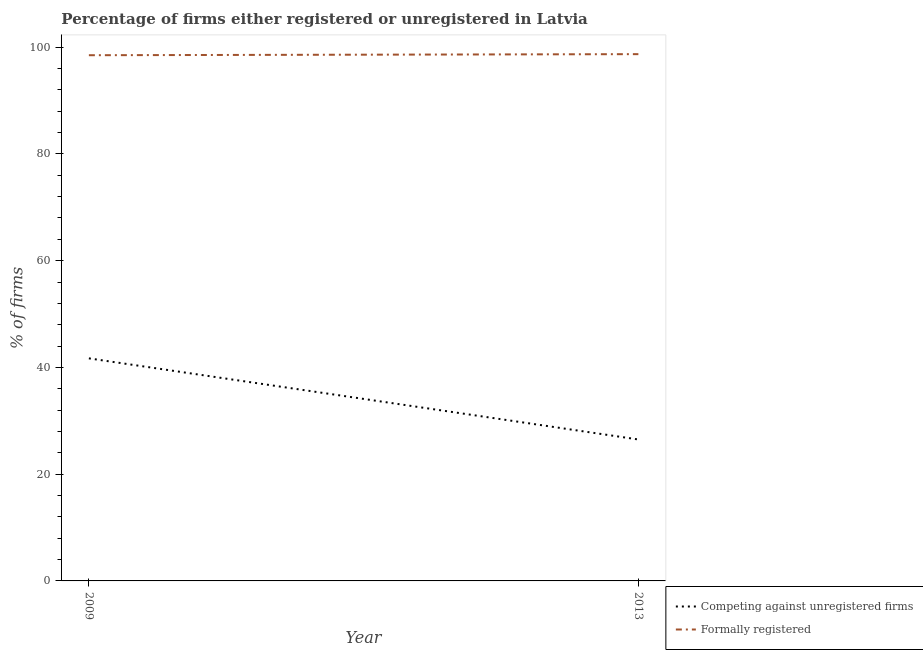Is the number of lines equal to the number of legend labels?
Offer a terse response. Yes. Across all years, what is the maximum percentage of registered firms?
Your response must be concise. 41.7. Across all years, what is the minimum percentage of formally registered firms?
Your answer should be very brief. 98.5. In which year was the percentage of formally registered firms maximum?
Make the answer very short. 2013. In which year was the percentage of registered firms minimum?
Make the answer very short. 2013. What is the total percentage of registered firms in the graph?
Give a very brief answer. 68.2. What is the difference between the percentage of registered firms in 2009 and that in 2013?
Ensure brevity in your answer.  15.2. What is the difference between the percentage of registered firms in 2009 and the percentage of formally registered firms in 2013?
Offer a very short reply. -57. What is the average percentage of formally registered firms per year?
Your answer should be very brief. 98.6. In the year 2009, what is the difference between the percentage of registered firms and percentage of formally registered firms?
Ensure brevity in your answer.  -56.8. What is the ratio of the percentage of formally registered firms in 2009 to that in 2013?
Offer a very short reply. 1. Is the percentage of formally registered firms in 2009 less than that in 2013?
Give a very brief answer. Yes. How many years are there in the graph?
Keep it short and to the point. 2. What is the difference between two consecutive major ticks on the Y-axis?
Offer a very short reply. 20. Are the values on the major ticks of Y-axis written in scientific E-notation?
Keep it short and to the point. No. Does the graph contain grids?
Your answer should be compact. No. How many legend labels are there?
Your answer should be very brief. 2. How are the legend labels stacked?
Give a very brief answer. Vertical. What is the title of the graph?
Ensure brevity in your answer.  Percentage of firms either registered or unregistered in Latvia. What is the label or title of the Y-axis?
Your answer should be compact. % of firms. What is the % of firms of Competing against unregistered firms in 2009?
Provide a short and direct response. 41.7. What is the % of firms in Formally registered in 2009?
Provide a short and direct response. 98.5. What is the % of firms of Competing against unregistered firms in 2013?
Make the answer very short. 26.5. What is the % of firms of Formally registered in 2013?
Give a very brief answer. 98.7. Across all years, what is the maximum % of firms in Competing against unregistered firms?
Your answer should be compact. 41.7. Across all years, what is the maximum % of firms of Formally registered?
Provide a short and direct response. 98.7. Across all years, what is the minimum % of firms in Formally registered?
Give a very brief answer. 98.5. What is the total % of firms of Competing against unregistered firms in the graph?
Make the answer very short. 68.2. What is the total % of firms in Formally registered in the graph?
Your answer should be compact. 197.2. What is the difference between the % of firms in Competing against unregistered firms in 2009 and that in 2013?
Make the answer very short. 15.2. What is the difference between the % of firms in Competing against unregistered firms in 2009 and the % of firms in Formally registered in 2013?
Offer a very short reply. -57. What is the average % of firms in Competing against unregistered firms per year?
Keep it short and to the point. 34.1. What is the average % of firms of Formally registered per year?
Offer a terse response. 98.6. In the year 2009, what is the difference between the % of firms of Competing against unregistered firms and % of firms of Formally registered?
Your response must be concise. -56.8. In the year 2013, what is the difference between the % of firms in Competing against unregistered firms and % of firms in Formally registered?
Offer a terse response. -72.2. What is the ratio of the % of firms of Competing against unregistered firms in 2009 to that in 2013?
Offer a terse response. 1.57. What is the ratio of the % of firms in Formally registered in 2009 to that in 2013?
Ensure brevity in your answer.  1. What is the difference between the highest and the lowest % of firms in Competing against unregistered firms?
Offer a terse response. 15.2. What is the difference between the highest and the lowest % of firms in Formally registered?
Keep it short and to the point. 0.2. 